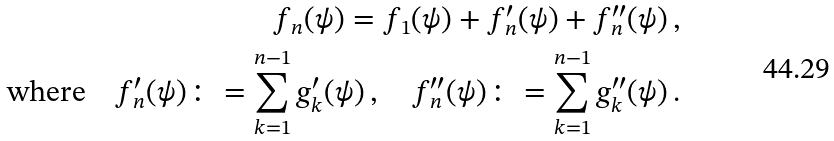<formula> <loc_0><loc_0><loc_500><loc_500>f _ { n } ( \psi ) = f _ { 1 } ( \psi ) + f _ { n } ^ { \prime } ( \psi ) + f _ { n } ^ { \prime \prime } ( \psi ) \, , \\ \text {where} \quad f _ { n } ^ { \prime } ( \psi ) \colon = \sum _ { k = 1 } ^ { n - 1 } g _ { k } ^ { \prime } ( \psi ) \, , \quad f _ { n } ^ { \prime \prime } ( \psi ) \colon = \sum _ { k = 1 } ^ { n - 1 } g _ { k } ^ { \prime \prime } ( \psi ) \, .</formula> 